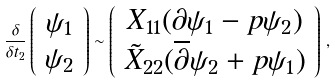<formula> <loc_0><loc_0><loc_500><loc_500>\frac { \delta } { \delta t _ { 2 } } \left ( \begin{array} { c } \psi _ { 1 } \\ \psi _ { 2 } \end{array} \right ) \sim \left ( \begin{array} { c } X _ { 1 1 } ( \partial \psi _ { 1 } - p \psi _ { 2 } ) \\ \tilde { X } _ { 2 2 } ( \overline { \partial } \psi _ { 2 } + p \psi _ { 1 } ) \end{array} \right ) \, ,</formula> 